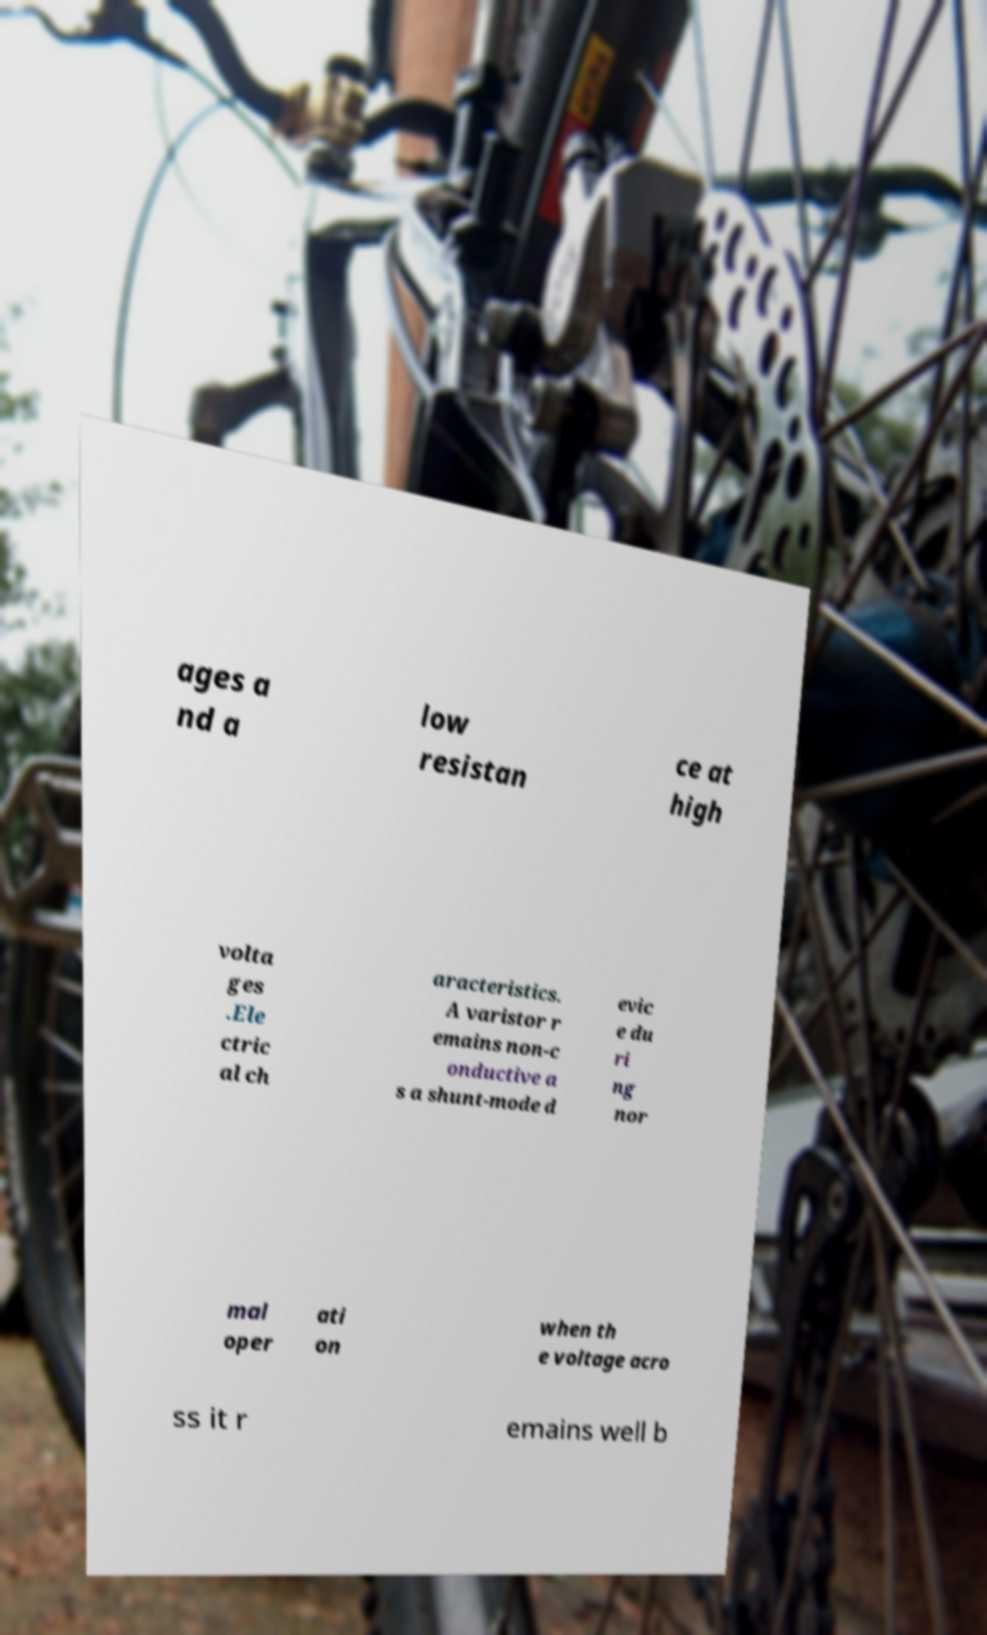I need the written content from this picture converted into text. Can you do that? ages a nd a low resistan ce at high volta ges .Ele ctric al ch aracteristics. A varistor r emains non-c onductive a s a shunt-mode d evic e du ri ng nor mal oper ati on when th e voltage acro ss it r emains well b 